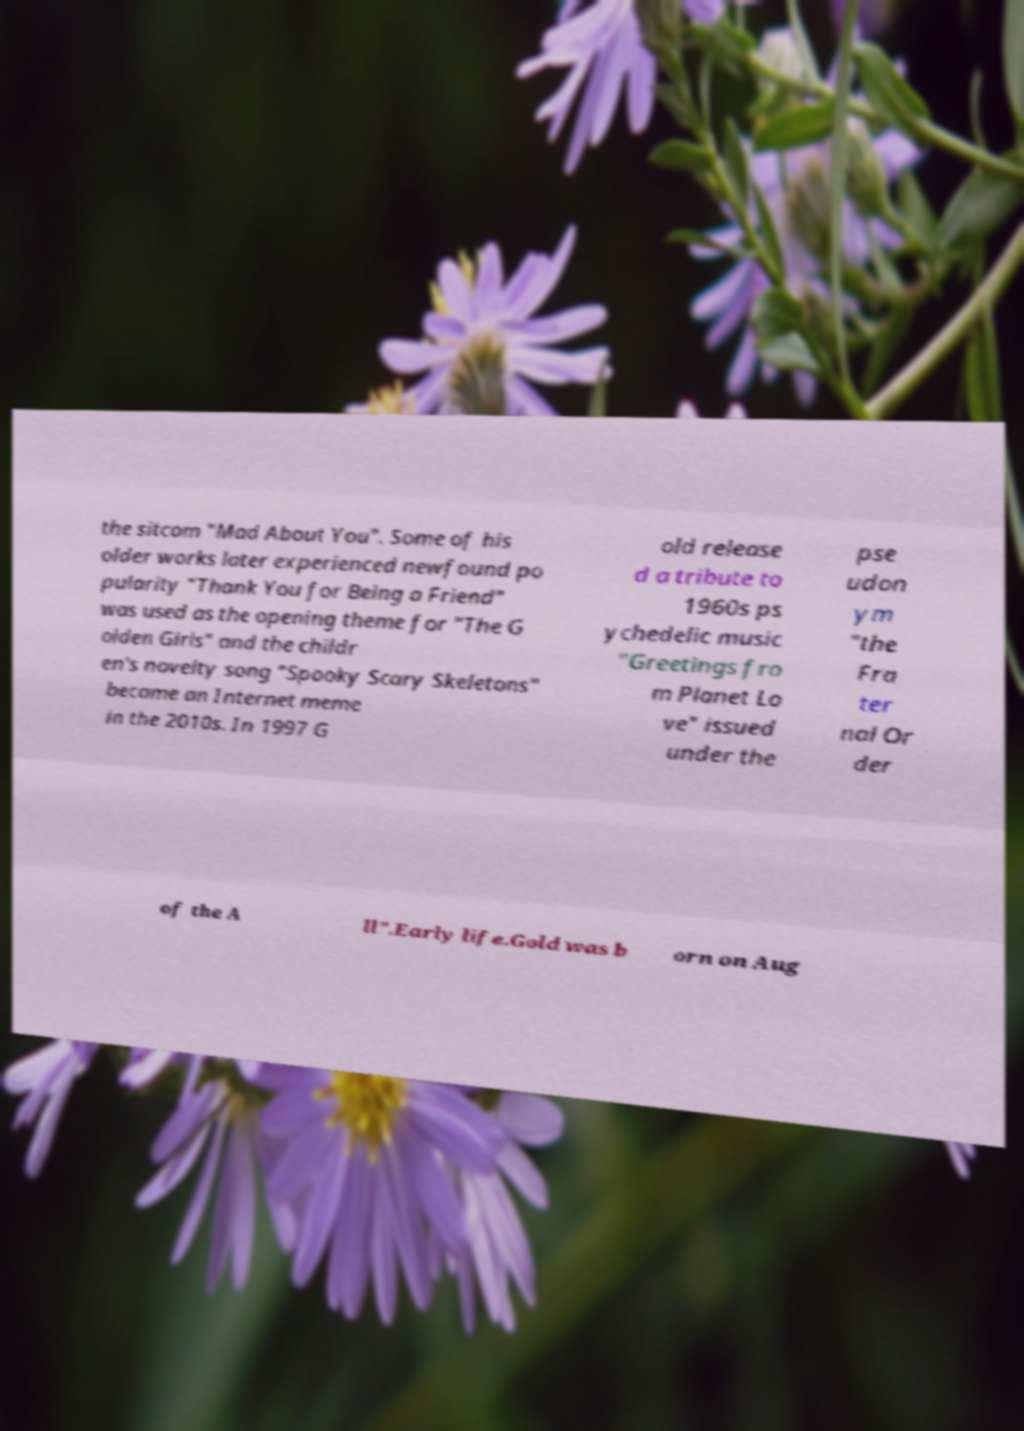There's text embedded in this image that I need extracted. Can you transcribe it verbatim? the sitcom "Mad About You". Some of his older works later experienced newfound po pularity "Thank You for Being a Friend" was used as the opening theme for "The G olden Girls" and the childr en's novelty song "Spooky Scary Skeletons" became an Internet meme in the 2010s. In 1997 G old release d a tribute to 1960s ps ychedelic music "Greetings fro m Planet Lo ve" issued under the pse udon ym "the Fra ter nal Or der of the A ll".Early life.Gold was b orn on Aug 